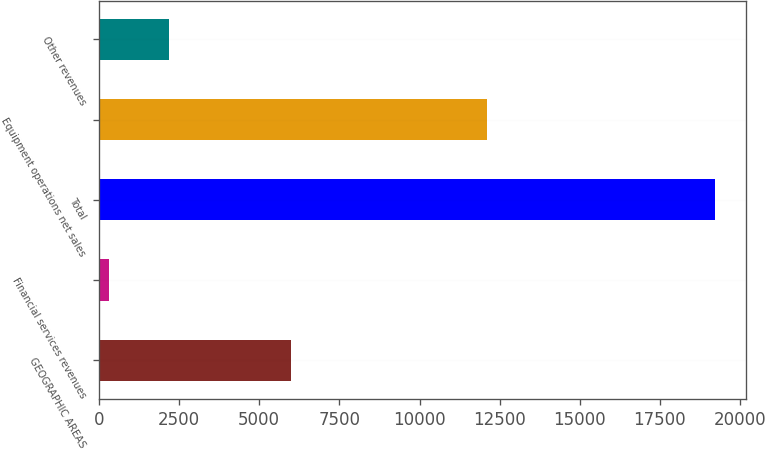Convert chart. <chart><loc_0><loc_0><loc_500><loc_500><bar_chart><fcel>GEOGRAPHIC AREAS<fcel>Financial services revenues<fcel>Total<fcel>Equipment operations net sales<fcel>Other revenues<nl><fcel>5978.4<fcel>306<fcel>19214<fcel>12109<fcel>2196.8<nl></chart> 